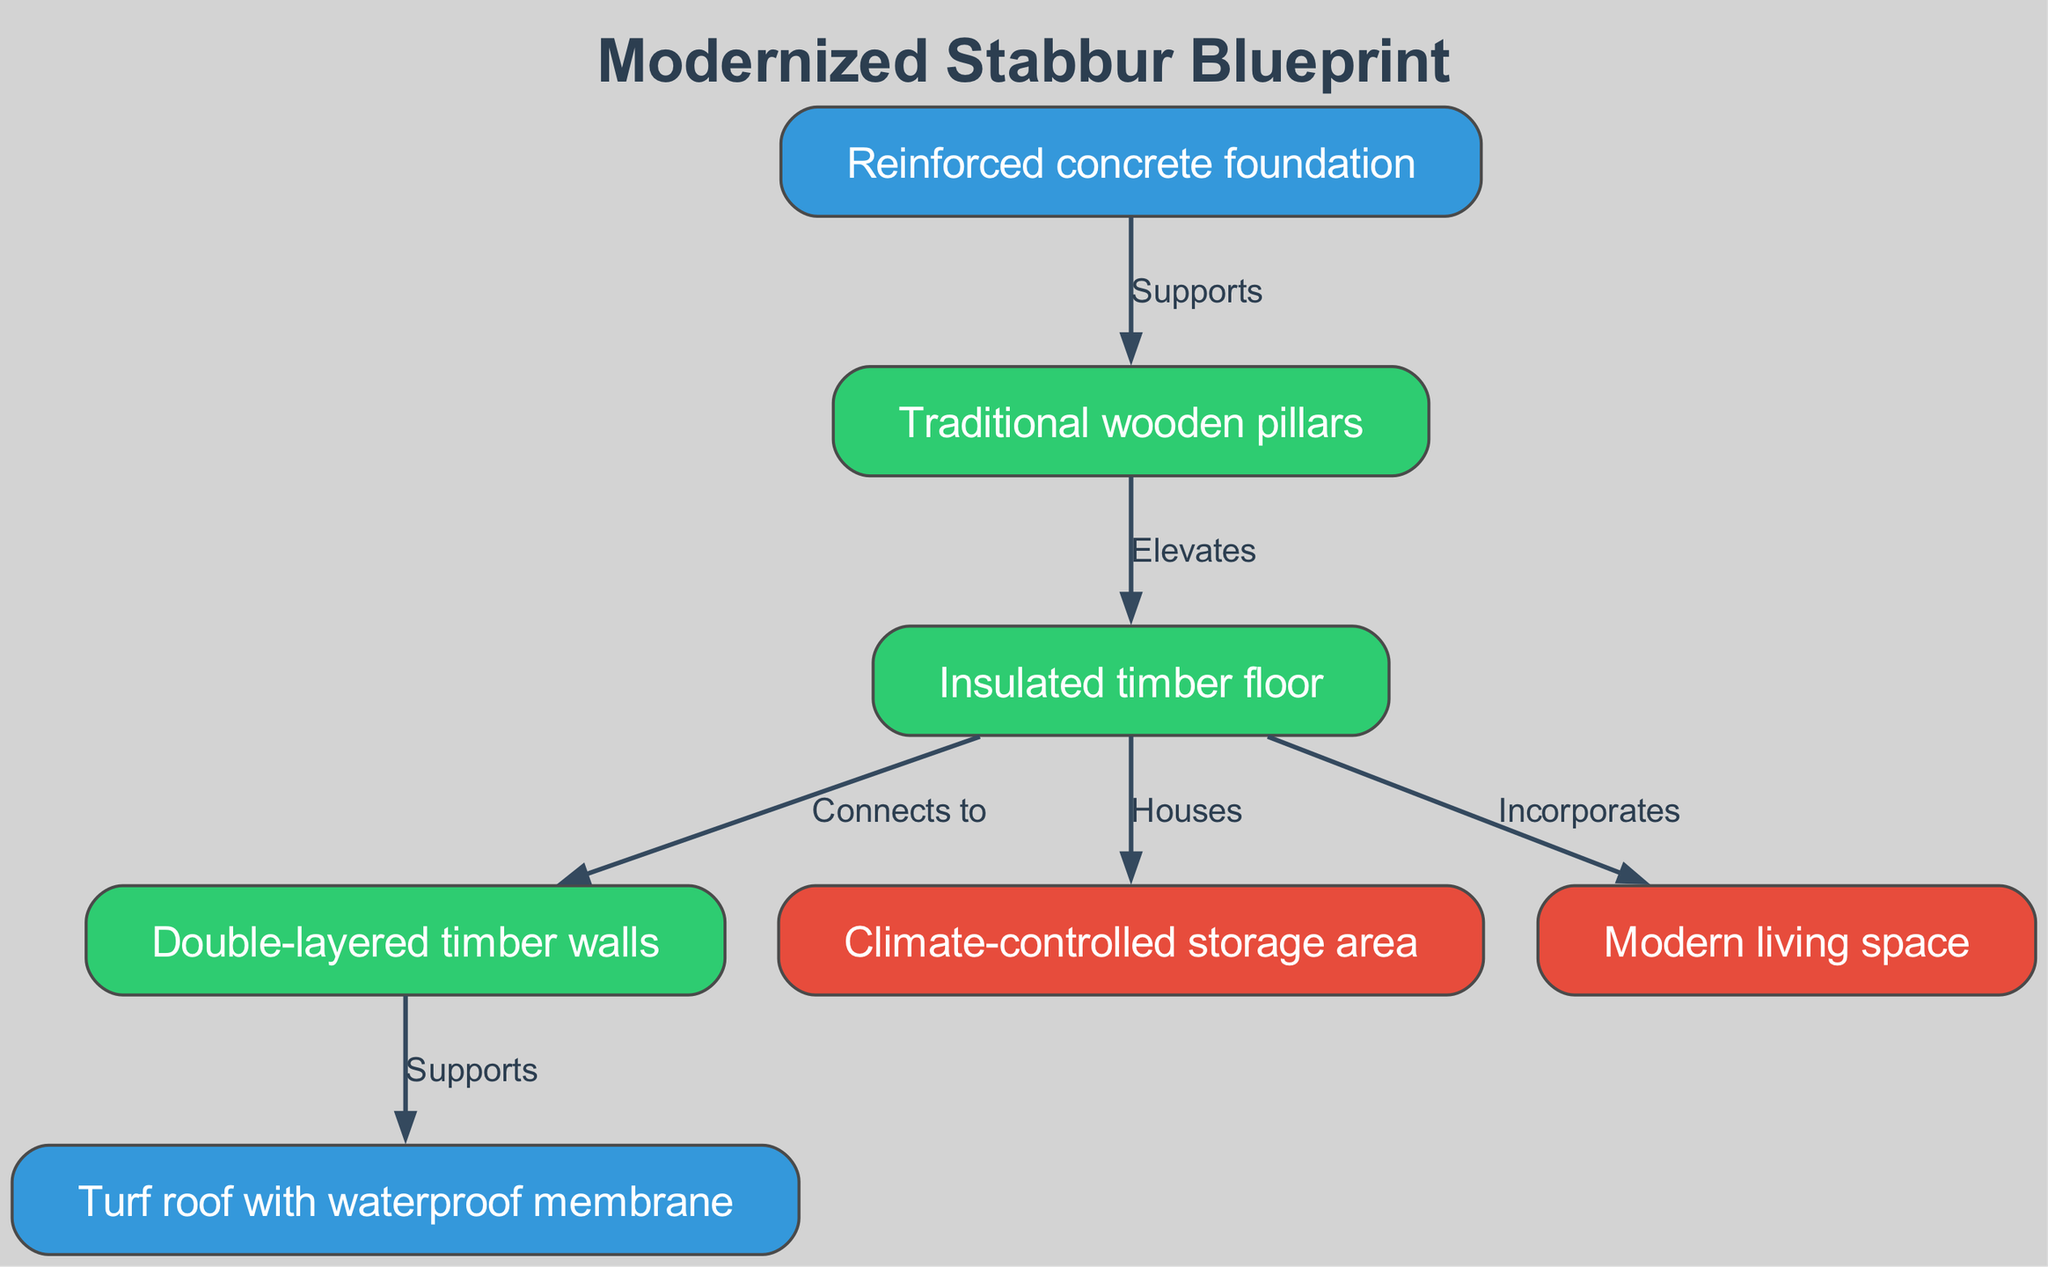What supports the traditional wooden pillars? The diagram indicates that the reinforced concrete foundation supports the traditional wooden pillars. This is represented by the edge labeled "Supports" connecting the two nodes.
Answer: Reinforced concrete foundation What type of roof is used in the modernized stabbur? The diagram labels the roof as a "Turf roof with waterproof membrane." This information is directly from the node for the roof.
Answer: Turf roof with waterproof membrane How many edges are there in the diagram? By counting the connections (edges) between the nodes, we see that there are a total of six edges in the diagram. Each connection indicates a unique relationship between the nodes.
Answer: 6 Which area does the insulated timber floor house? The insulated timber floor houses both the climate-controlled storage area and the modern living space. We can observe this by looking at the edges labeled "Houses" and "Incorporates."
Answer: Climate-controlled storage area and modern living space Which components are connected by the edge labeled "Supports"? The edge labeled "Supports" connects the walls and the roof, indicating that the walls provide support for the roof structure above. This can be confirmed by examining the diagram's specific labels on the edges.
Answer: Walls and roof What material is used for the walls in the modernized stabbur? The diagram specifies that the walls are made of "Double-layered timber walls," as indicated in the node label for the walls. This is a direct reference from the diagram.
Answer: Double-layered timber walls What connects to the insulated timber floor? The insulated timber floor connects to the traditional wooden pillars, double-layered timber walls, climate-controlled storage area, and modern living space. This is confirmed by examining the edges emanating from the floor node.
Answer: Traditional wooden pillars, double-layered timber walls, climate-controlled storage area, and modern living space How do the walls relate to the roof? The walls support the roof, as indicated by the edge labeled "Supports" linking the walls and roof nodes in the diagram. This relationship establishes the structural integrity of the building's upper section.
Answer: Supports What is the intermediate element between the foundation and the floor? The traditional wooden pillars serve as the intermediate element, as they elevate the floor above the reinforced concrete foundation, demonstrating the structural arrangement indicated by the diagram.
Answer: Traditional wooden pillars 